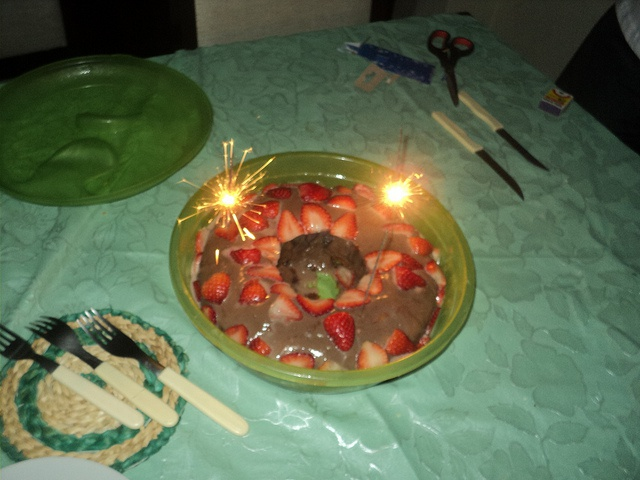Describe the objects in this image and their specific colors. I can see dining table in darkgreen, teal, and black tones, bowl in black, olive, brown, and maroon tones, fork in black, khaki, gray, and darkgreen tones, fork in black, khaki, gray, and tan tones, and fork in black, beige, and tan tones in this image. 